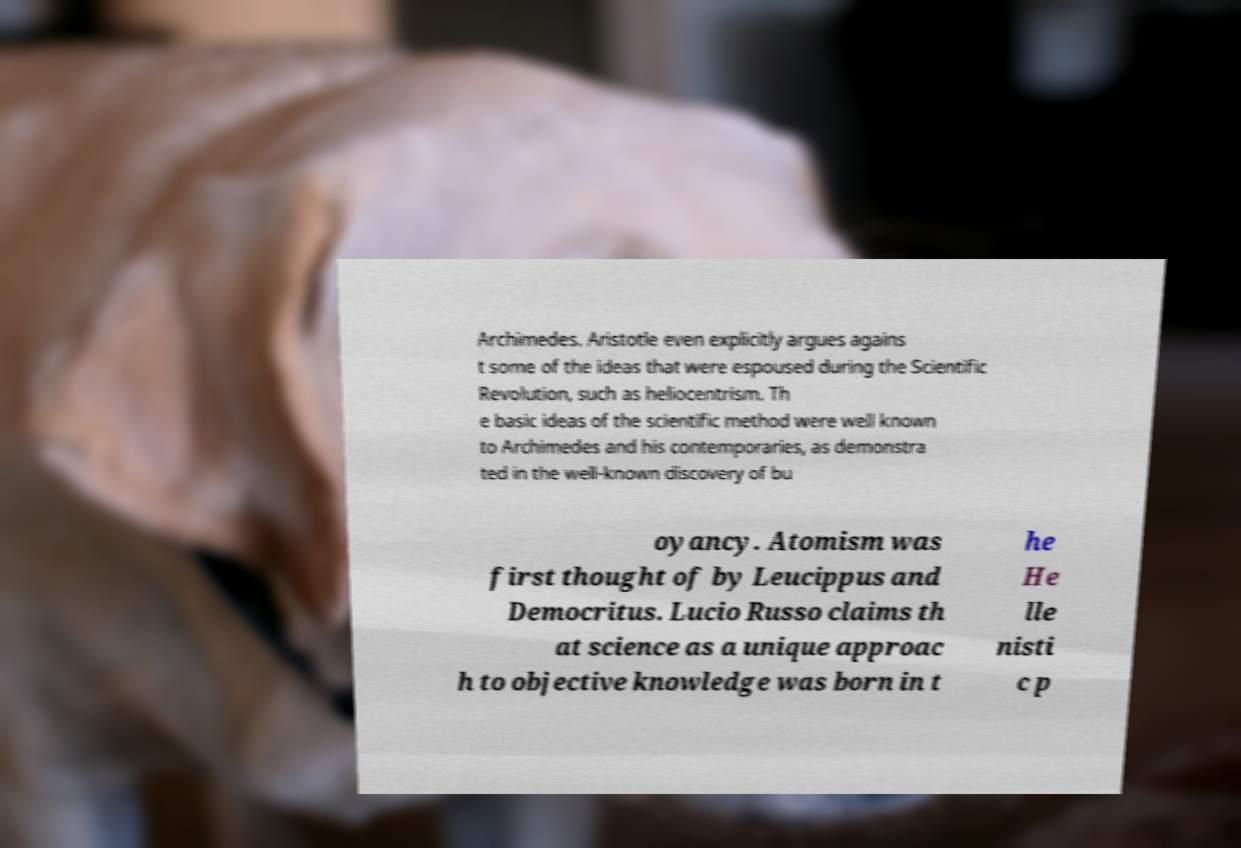Please read and relay the text visible in this image. What does it say? Archimedes. Aristotle even explicitly argues agains t some of the ideas that were espoused during the Scientific Revolution, such as heliocentrism. Th e basic ideas of the scientific method were well known to Archimedes and his contemporaries, as demonstra ted in the well-known discovery of bu oyancy. Atomism was first thought of by Leucippus and Democritus. Lucio Russo claims th at science as a unique approac h to objective knowledge was born in t he He lle nisti c p 